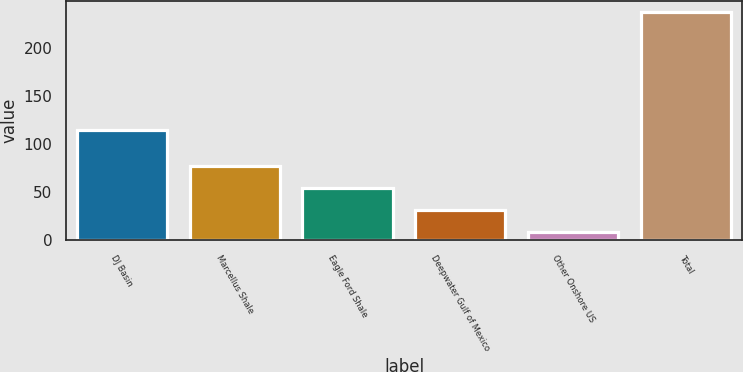Convert chart. <chart><loc_0><loc_0><loc_500><loc_500><bar_chart><fcel>DJ Basin<fcel>Marcellus Shale<fcel>Eagle Ford Shale<fcel>Deepwater Gulf of Mexico<fcel>Other Onshore US<fcel>Total<nl><fcel>115<fcel>77<fcel>53.8<fcel>30.9<fcel>8<fcel>237<nl></chart> 